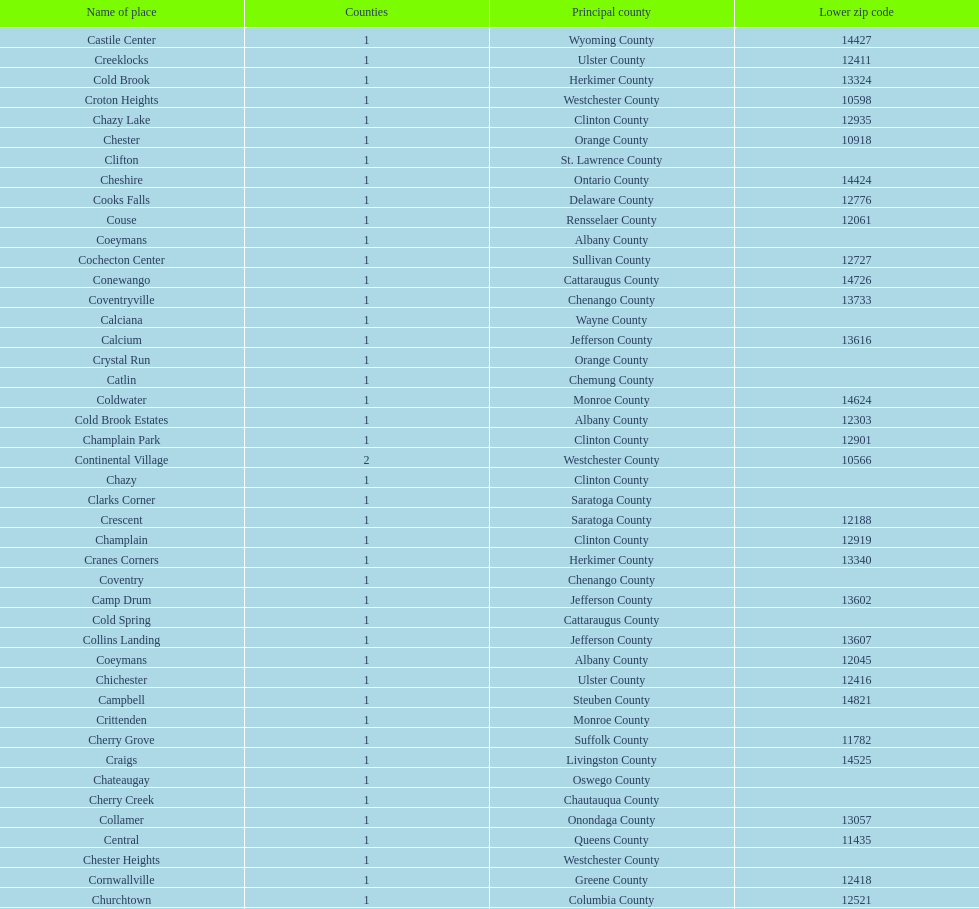Which place has the lowest, lower zip code? Cooper. 